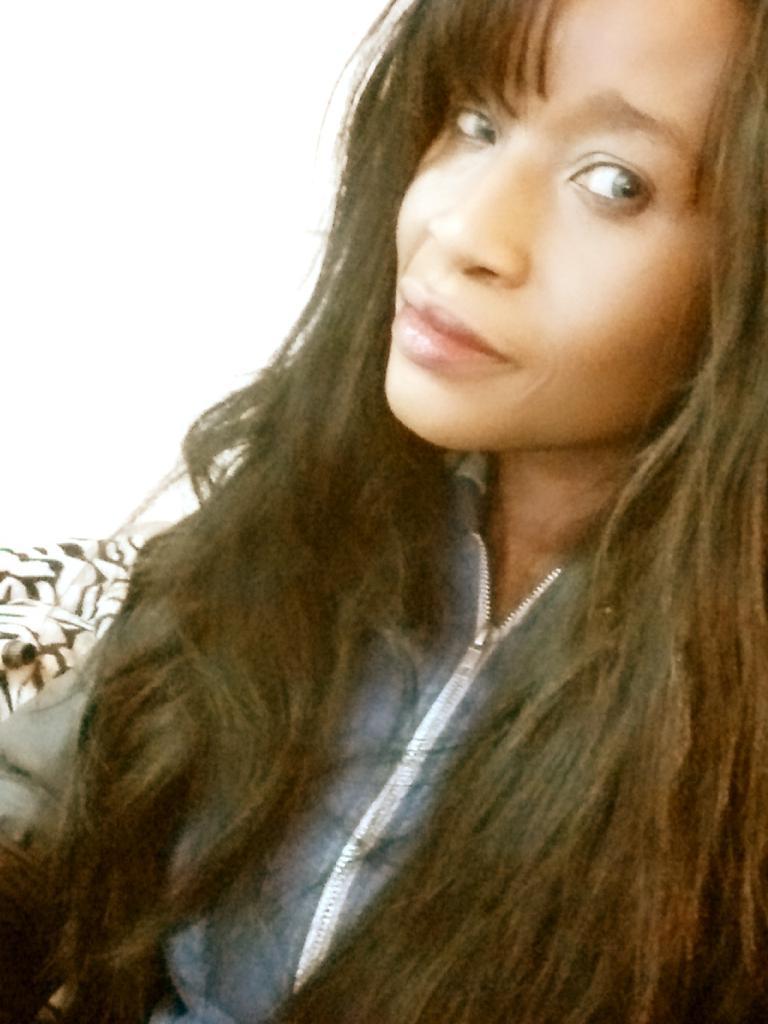Describe this image in one or two sentences. In the image I can see a lady with long hair. 